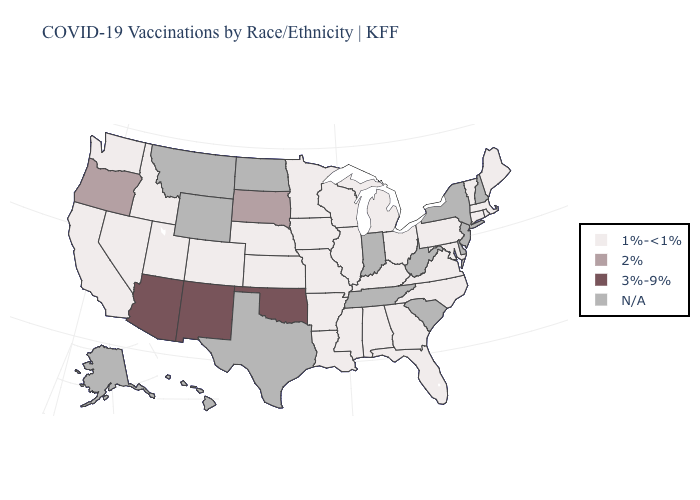What is the value of Pennsylvania?
Write a very short answer. 1%-<1%. What is the value of Arkansas?
Short answer required. 1%-<1%. What is the highest value in states that border Utah?
Answer briefly. 3%-9%. Does Washington have the highest value in the West?
Concise answer only. No. What is the lowest value in states that border Ohio?
Concise answer only. 1%-<1%. Name the states that have a value in the range 1%-<1%?
Quick response, please. Alabama, Arkansas, California, Colorado, Connecticut, Florida, Georgia, Idaho, Illinois, Iowa, Kansas, Kentucky, Louisiana, Maine, Maryland, Massachusetts, Michigan, Minnesota, Mississippi, Missouri, Nebraska, Nevada, North Carolina, Ohio, Pennsylvania, Rhode Island, Utah, Vermont, Virginia, Washington, Wisconsin. Name the states that have a value in the range 1%-<1%?
Short answer required. Alabama, Arkansas, California, Colorado, Connecticut, Florida, Georgia, Idaho, Illinois, Iowa, Kansas, Kentucky, Louisiana, Maine, Maryland, Massachusetts, Michigan, Minnesota, Mississippi, Missouri, Nebraska, Nevada, North Carolina, Ohio, Pennsylvania, Rhode Island, Utah, Vermont, Virginia, Washington, Wisconsin. What is the value of Kentucky?
Keep it brief. 1%-<1%. What is the lowest value in the USA?
Be succinct. 1%-<1%. What is the value of Georgia?
Answer briefly. 1%-<1%. Which states have the lowest value in the USA?
Keep it brief. Alabama, Arkansas, California, Colorado, Connecticut, Florida, Georgia, Idaho, Illinois, Iowa, Kansas, Kentucky, Louisiana, Maine, Maryland, Massachusetts, Michigan, Minnesota, Mississippi, Missouri, Nebraska, Nevada, North Carolina, Ohio, Pennsylvania, Rhode Island, Utah, Vermont, Virginia, Washington, Wisconsin. What is the value of Vermont?
Give a very brief answer. 1%-<1%. What is the value of Ohio?
Keep it brief. 1%-<1%. 